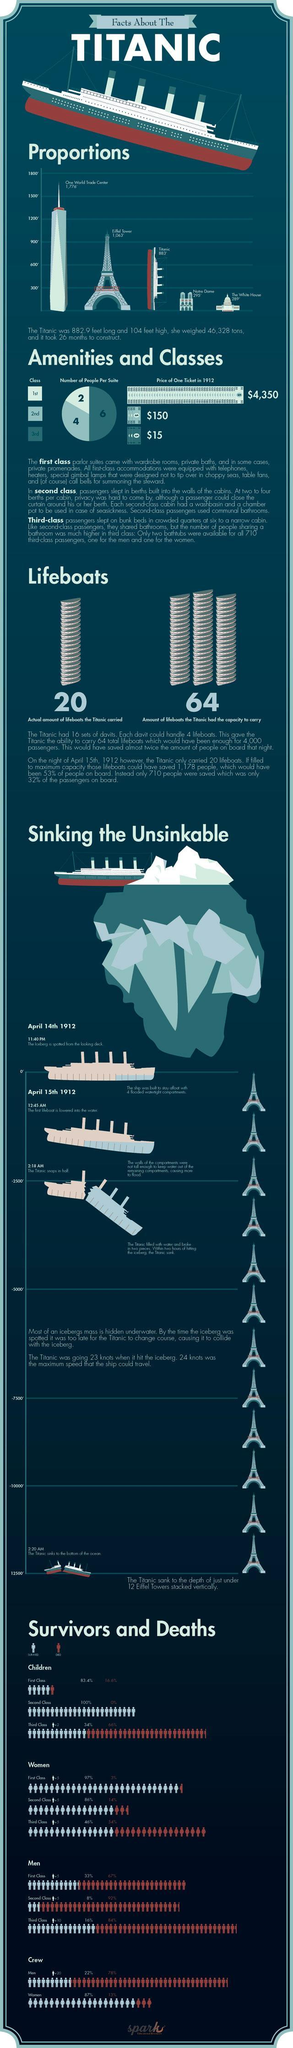in which class was the maximum deaths
Answer the question with a short phrase. third what is shorter than Titanic but taller than white house? notre dome what was the difference between the maximum speed allowed and the speed of the titanic 1 What was the difference in price between the 2nd class and 3rd class ticket 135 in the graph shown, which one is longer, Eiffel tower or Titanic Eiffel tower how many people could the 3rd class suite accomodate 6 how much more lifeboats could the titanic carry? 44 